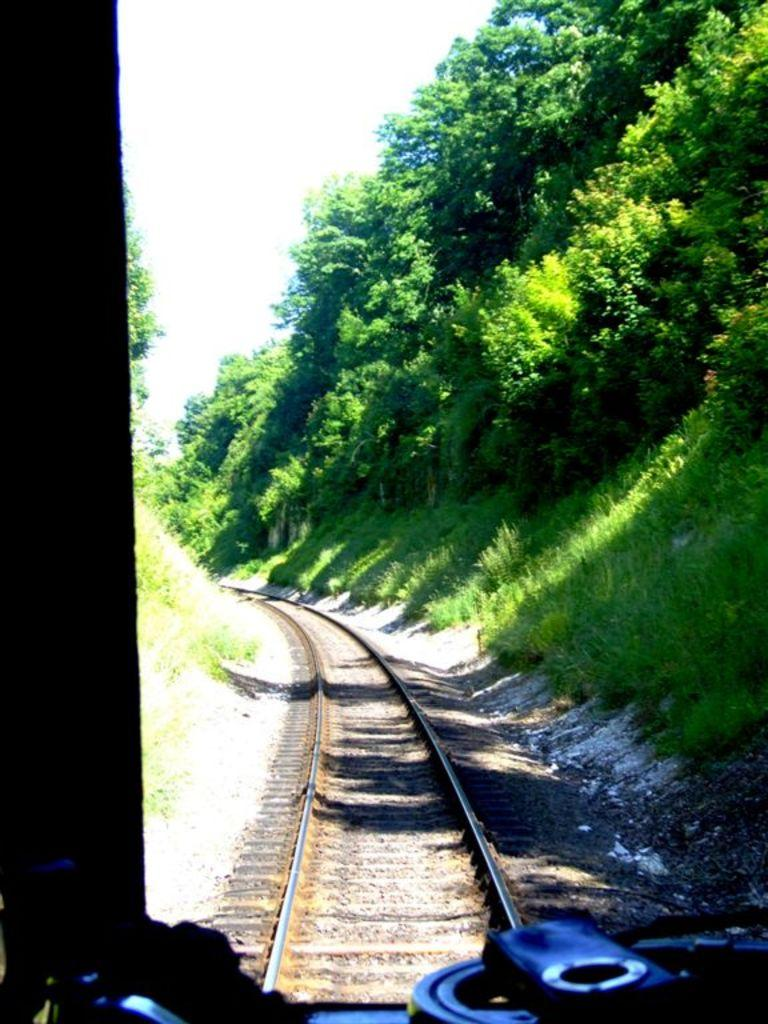What is the main feature of the image? There is a track in the image. What can be seen near the track? There are many trees near the track. What is visible in the front of the image? There are some objects visible in the front of the image. How would you describe the sky in the background? The sky in the background is white. Where are the geese hiding in the image? There are no geese present in the image. Can you tell me how many lettuce leaves are on the track? There is no lettuce present in the image. 